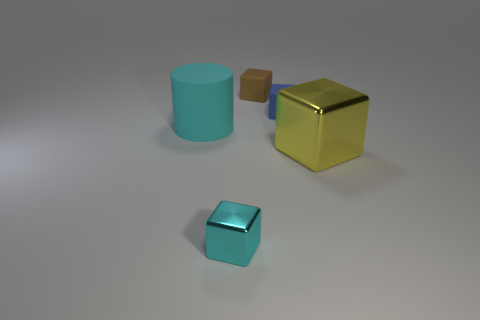Subtract all brown cubes. How many cubes are left? 3 Subtract all small blocks. How many blocks are left? 1 Add 3 small brown cubes. How many objects exist? 8 Subtract all cylinders. How many objects are left? 4 Subtract all purple blocks. Subtract all green balls. How many blocks are left? 4 Subtract 0 red blocks. How many objects are left? 5 Subtract all tiny brown rubber things. Subtract all tiny blue rubber blocks. How many objects are left? 3 Add 2 tiny brown blocks. How many tiny brown blocks are left? 3 Add 4 yellow cylinders. How many yellow cylinders exist? 4 